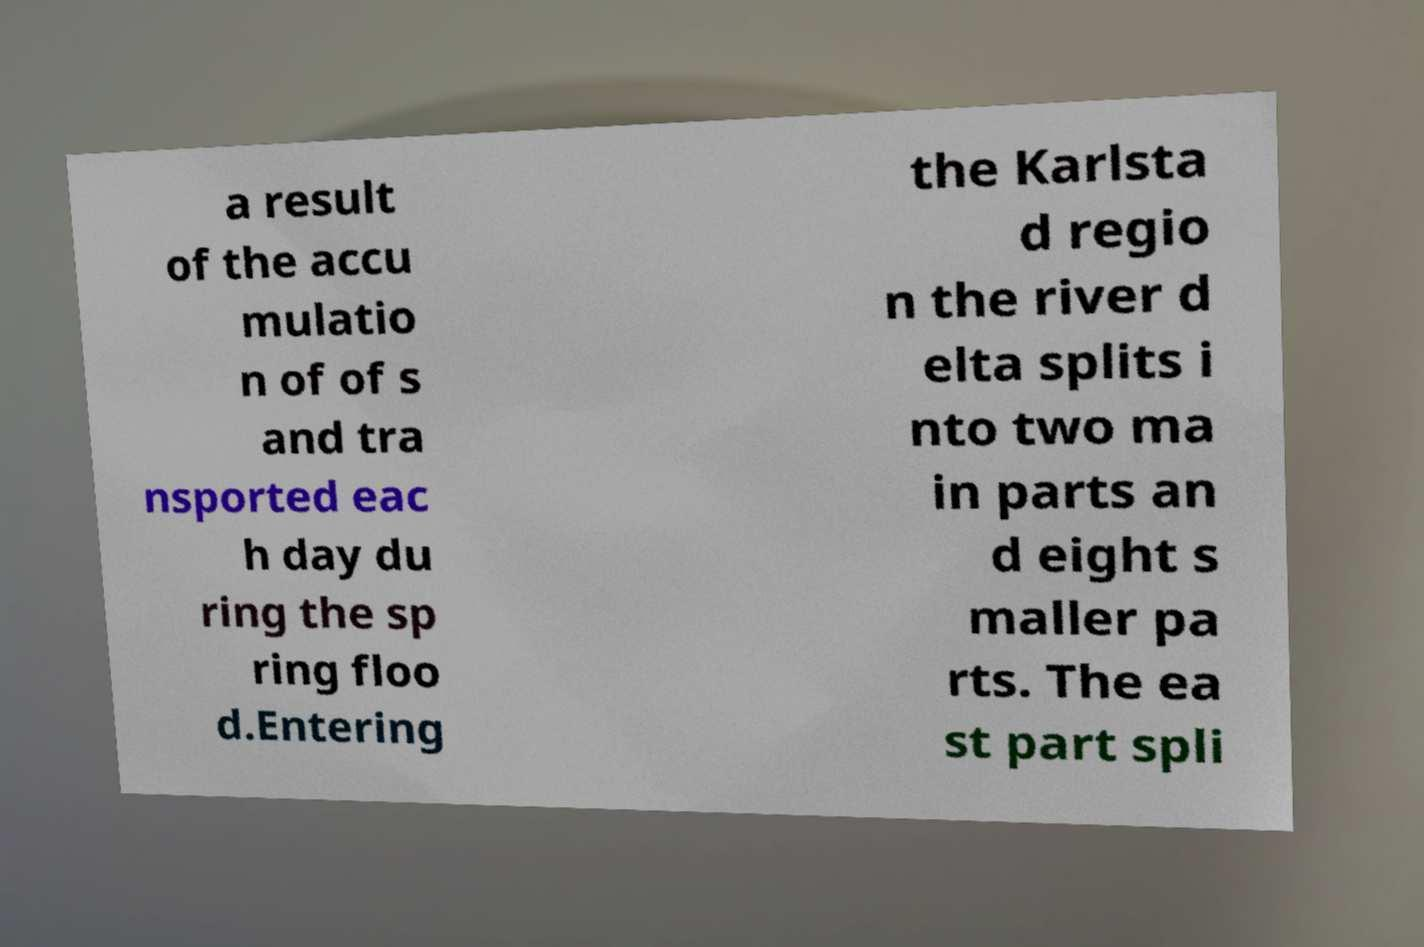Can you accurately transcribe the text from the provided image for me? a result of the accu mulatio n of of s and tra nsported eac h day du ring the sp ring floo d.Entering the Karlsta d regio n the river d elta splits i nto two ma in parts an d eight s maller pa rts. The ea st part spli 